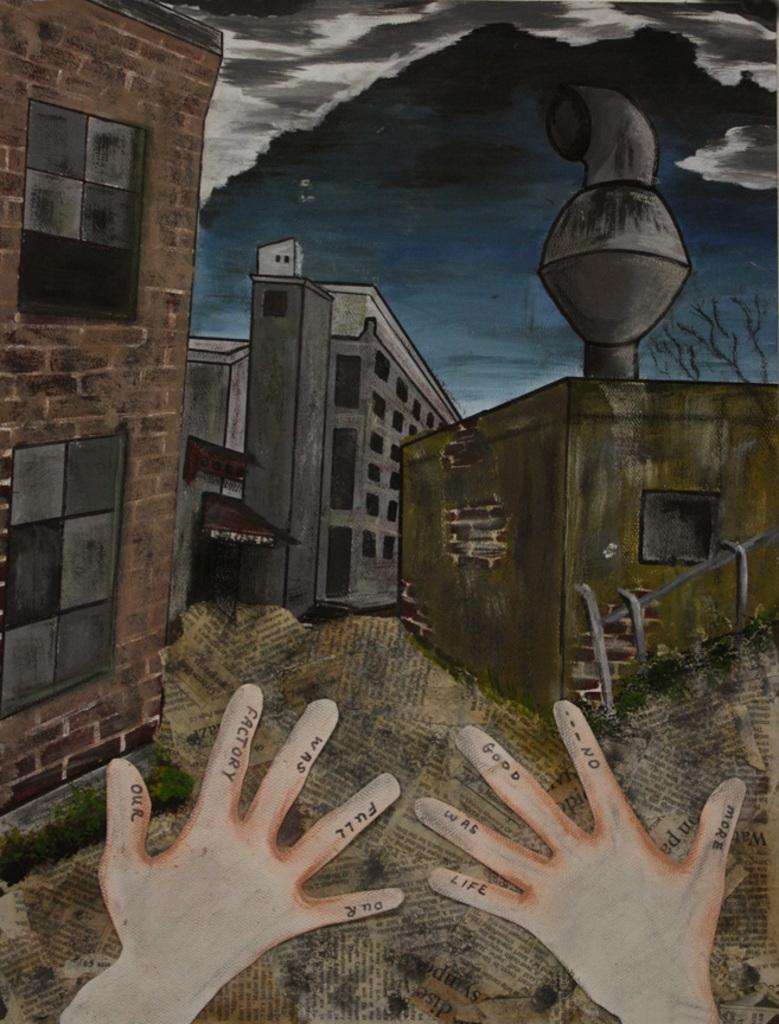What type of structures can be seen in the image? There are many buildings in the image. What colors are the buildings in the image? The buildings are in brown, ash, and green colors. What can be seen in the background of the image? There are clouds and the sky visible in the background of the image. Can you describe any human elements in the image? Yes, there are people's hands visible in the image. What type of lock can be seen on the cannon in the image? There is no cannon present in the image, so there is no lock to be seen. How many visitors are visible in the image? There is no indication of visitors in the image; only buildings, colors, background elements, and hands are mentioned. 